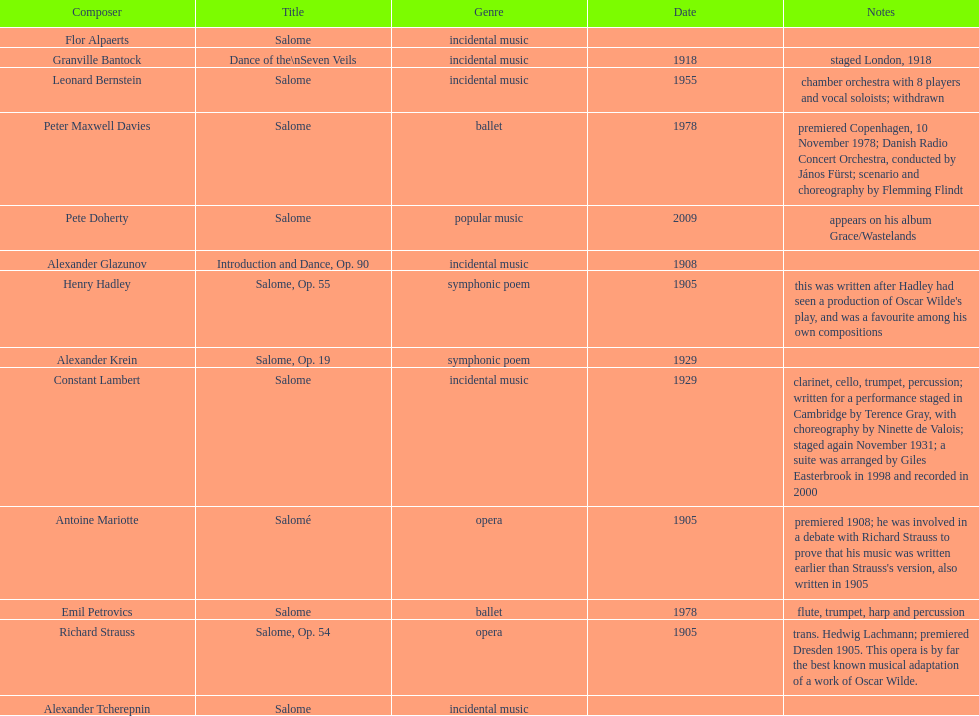How many works were made in the incidental music genre? 6. 